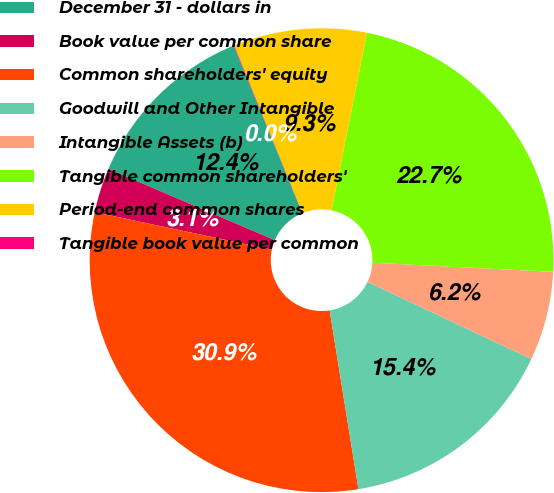Convert chart to OTSL. <chart><loc_0><loc_0><loc_500><loc_500><pie_chart><fcel>December 31 - dollars in<fcel>Book value per common share<fcel>Common shareholders' equity<fcel>Goodwill and Other Intangible<fcel>Intangible Assets (b)<fcel>Tangible common shareholders'<fcel>Period-end common shares<fcel>Tangible book value per common<nl><fcel>12.37%<fcel>3.12%<fcel>30.86%<fcel>15.45%<fcel>6.21%<fcel>22.66%<fcel>9.29%<fcel>0.04%<nl></chart> 